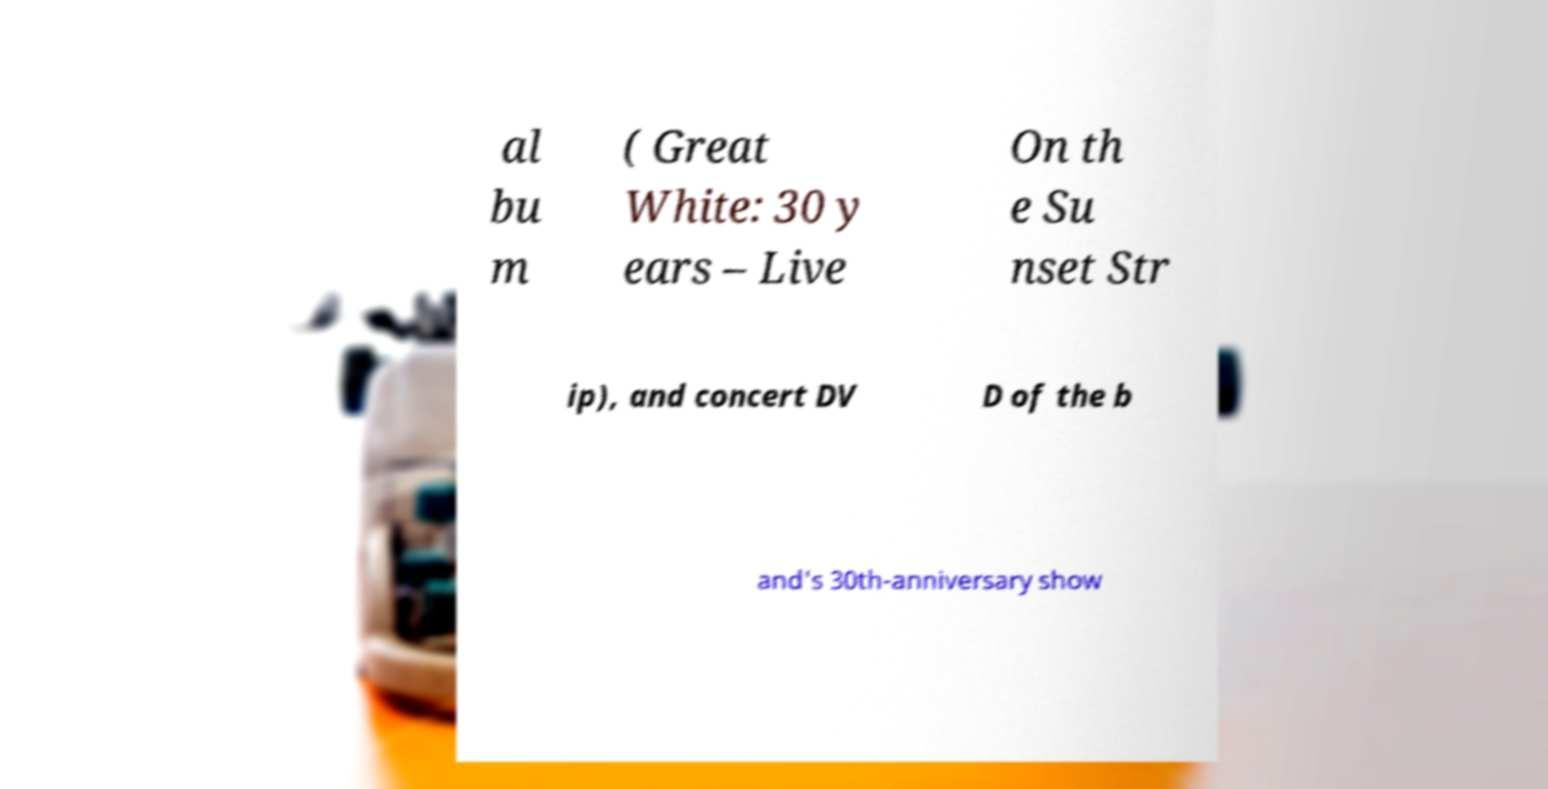Please identify and transcribe the text found in this image. al bu m ( Great White: 30 y ears – Live On th e Su nset Str ip), and concert DV D of the b and's 30th-anniversary show 